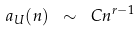Convert formula to latex. <formula><loc_0><loc_0><loc_500><loc_500>a _ { U } ( n ) \ \sim \ C n ^ { r - 1 }</formula> 